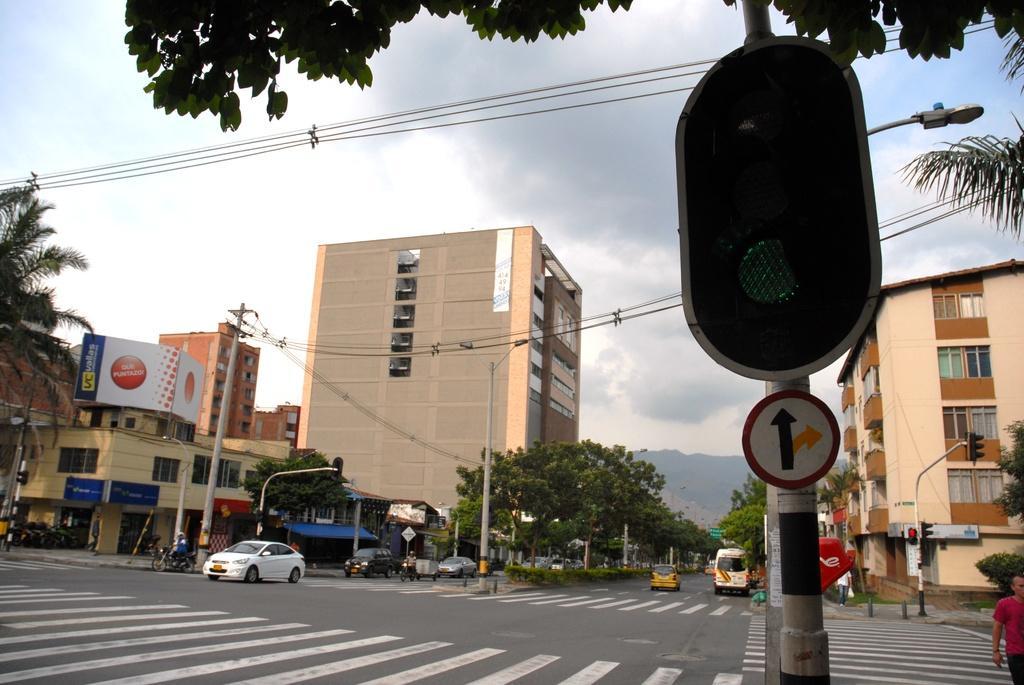Describe this image in one or two sentences. In this image I can see buildings, hoardings, poles, trees, vehicles, sign boards, signal lights, people, plants, cloudy sky and objects. 